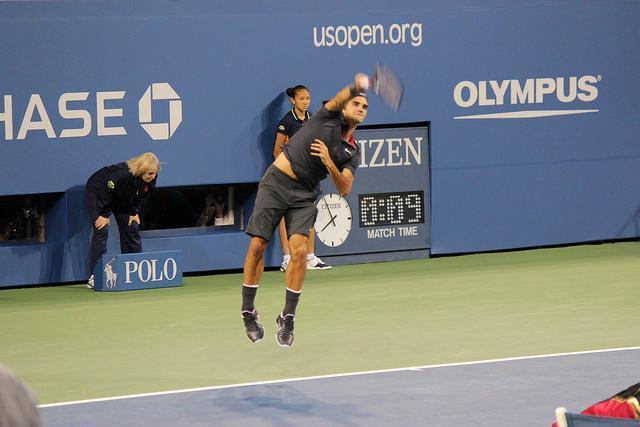How many people can be seen?
Give a very brief answer. 3. 